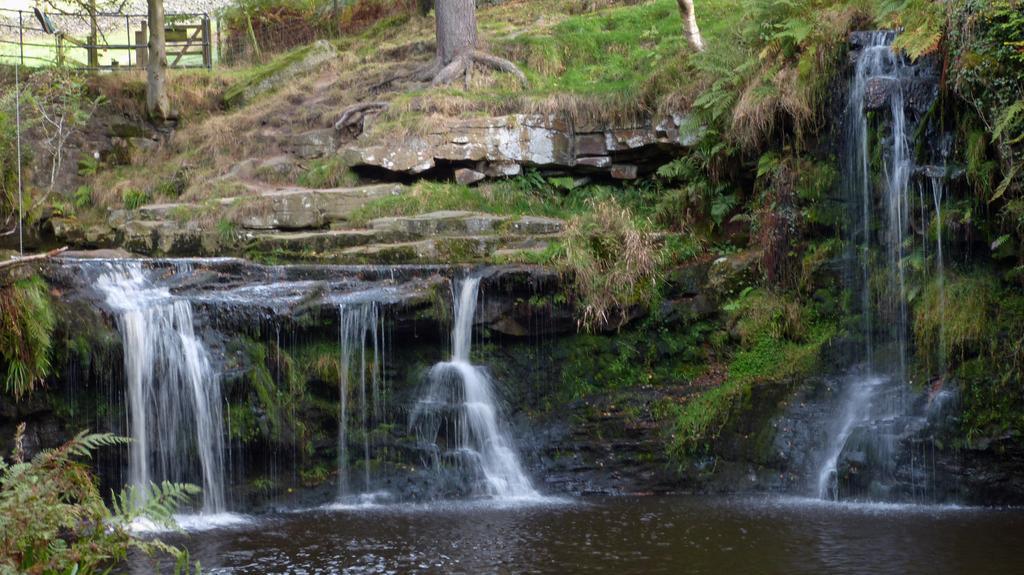Please provide a concise description of this image. In this image, we can see some plants, trees and grass. There is a waterfall in the middle of the image. 